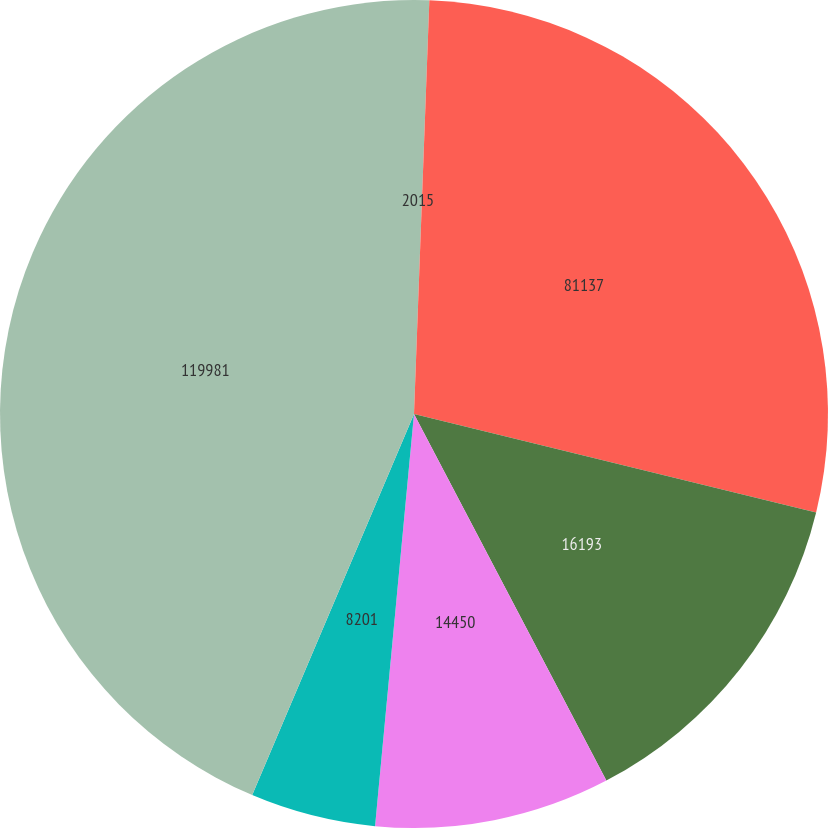Convert chart to OTSL. <chart><loc_0><loc_0><loc_500><loc_500><pie_chart><fcel>2015<fcel>81137<fcel>16193<fcel>14450<fcel>8201<fcel>119981<nl><fcel>0.59%<fcel>28.23%<fcel>13.49%<fcel>9.19%<fcel>4.89%<fcel>43.61%<nl></chart> 